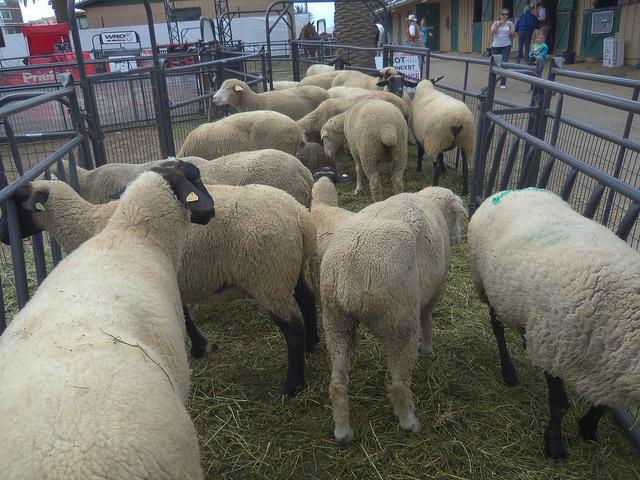Have the sheep been recently shorn?
Quick response, please. Yes. Are there any adults visible?
Short answer required. Yes. What color is the sheep on the right marked with?
Quick response, please. Blue. Are most of the sheep eating?
Answer briefly. No. How many black headed sheep are in the picture?
Short answer required. 2. Why are the sheep behind a gate?
Answer briefly. Called. What are they doing?
Short answer required. Standing. Do the sheep look crowded?
Write a very short answer. Yes. 